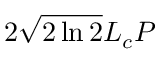Convert formula to latex. <formula><loc_0><loc_0><loc_500><loc_500>2 \sqrt { 2 \ln 2 } L _ { c } P</formula> 